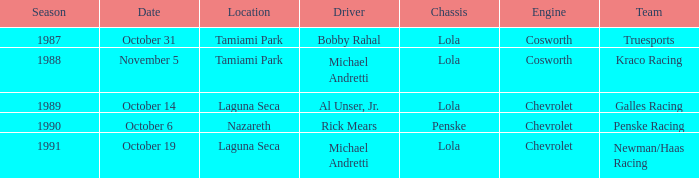At which location did Rick Mears drive? Nazareth. 